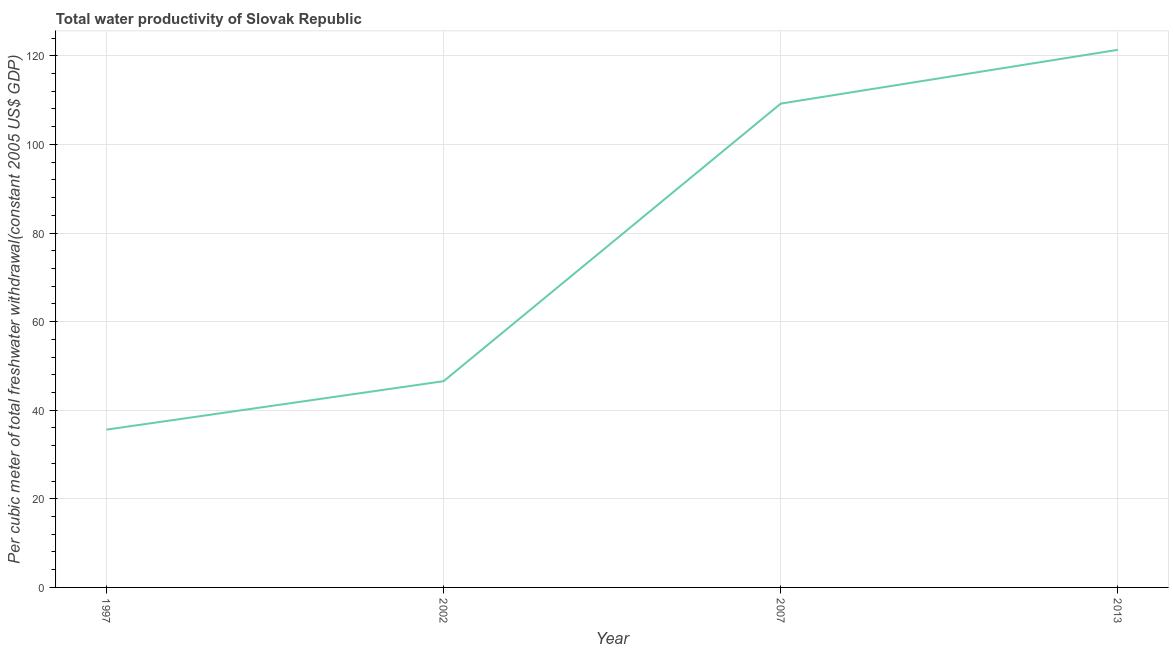What is the total water productivity in 1997?
Offer a very short reply. 35.62. Across all years, what is the maximum total water productivity?
Make the answer very short. 121.36. Across all years, what is the minimum total water productivity?
Keep it short and to the point. 35.62. In which year was the total water productivity maximum?
Offer a terse response. 2013. In which year was the total water productivity minimum?
Keep it short and to the point. 1997. What is the sum of the total water productivity?
Your answer should be very brief. 312.75. What is the difference between the total water productivity in 1997 and 2007?
Your answer should be compact. -73.6. What is the average total water productivity per year?
Give a very brief answer. 78.19. What is the median total water productivity?
Keep it short and to the point. 77.89. What is the ratio of the total water productivity in 2002 to that in 2013?
Provide a succinct answer. 0.38. Is the difference between the total water productivity in 1997 and 2013 greater than the difference between any two years?
Offer a very short reply. Yes. What is the difference between the highest and the second highest total water productivity?
Offer a very short reply. 12.14. What is the difference between the highest and the lowest total water productivity?
Ensure brevity in your answer.  85.74. In how many years, is the total water productivity greater than the average total water productivity taken over all years?
Offer a terse response. 2. How many lines are there?
Offer a very short reply. 1. How many years are there in the graph?
Provide a short and direct response. 4. What is the difference between two consecutive major ticks on the Y-axis?
Your answer should be very brief. 20. Does the graph contain any zero values?
Ensure brevity in your answer.  No. What is the title of the graph?
Offer a terse response. Total water productivity of Slovak Republic. What is the label or title of the Y-axis?
Offer a very short reply. Per cubic meter of total freshwater withdrawal(constant 2005 US$ GDP). What is the Per cubic meter of total freshwater withdrawal(constant 2005 US$ GDP) in 1997?
Your answer should be very brief. 35.62. What is the Per cubic meter of total freshwater withdrawal(constant 2005 US$ GDP) of 2002?
Provide a short and direct response. 46.55. What is the Per cubic meter of total freshwater withdrawal(constant 2005 US$ GDP) of 2007?
Offer a terse response. 109.22. What is the Per cubic meter of total freshwater withdrawal(constant 2005 US$ GDP) of 2013?
Make the answer very short. 121.36. What is the difference between the Per cubic meter of total freshwater withdrawal(constant 2005 US$ GDP) in 1997 and 2002?
Make the answer very short. -10.94. What is the difference between the Per cubic meter of total freshwater withdrawal(constant 2005 US$ GDP) in 1997 and 2007?
Offer a very short reply. -73.6. What is the difference between the Per cubic meter of total freshwater withdrawal(constant 2005 US$ GDP) in 1997 and 2013?
Offer a very short reply. -85.74. What is the difference between the Per cubic meter of total freshwater withdrawal(constant 2005 US$ GDP) in 2002 and 2007?
Offer a terse response. -62.66. What is the difference between the Per cubic meter of total freshwater withdrawal(constant 2005 US$ GDP) in 2002 and 2013?
Make the answer very short. -74.8. What is the difference between the Per cubic meter of total freshwater withdrawal(constant 2005 US$ GDP) in 2007 and 2013?
Offer a terse response. -12.14. What is the ratio of the Per cubic meter of total freshwater withdrawal(constant 2005 US$ GDP) in 1997 to that in 2002?
Provide a succinct answer. 0.77. What is the ratio of the Per cubic meter of total freshwater withdrawal(constant 2005 US$ GDP) in 1997 to that in 2007?
Provide a short and direct response. 0.33. What is the ratio of the Per cubic meter of total freshwater withdrawal(constant 2005 US$ GDP) in 1997 to that in 2013?
Provide a short and direct response. 0.29. What is the ratio of the Per cubic meter of total freshwater withdrawal(constant 2005 US$ GDP) in 2002 to that in 2007?
Your answer should be compact. 0.43. What is the ratio of the Per cubic meter of total freshwater withdrawal(constant 2005 US$ GDP) in 2002 to that in 2013?
Ensure brevity in your answer.  0.38. 